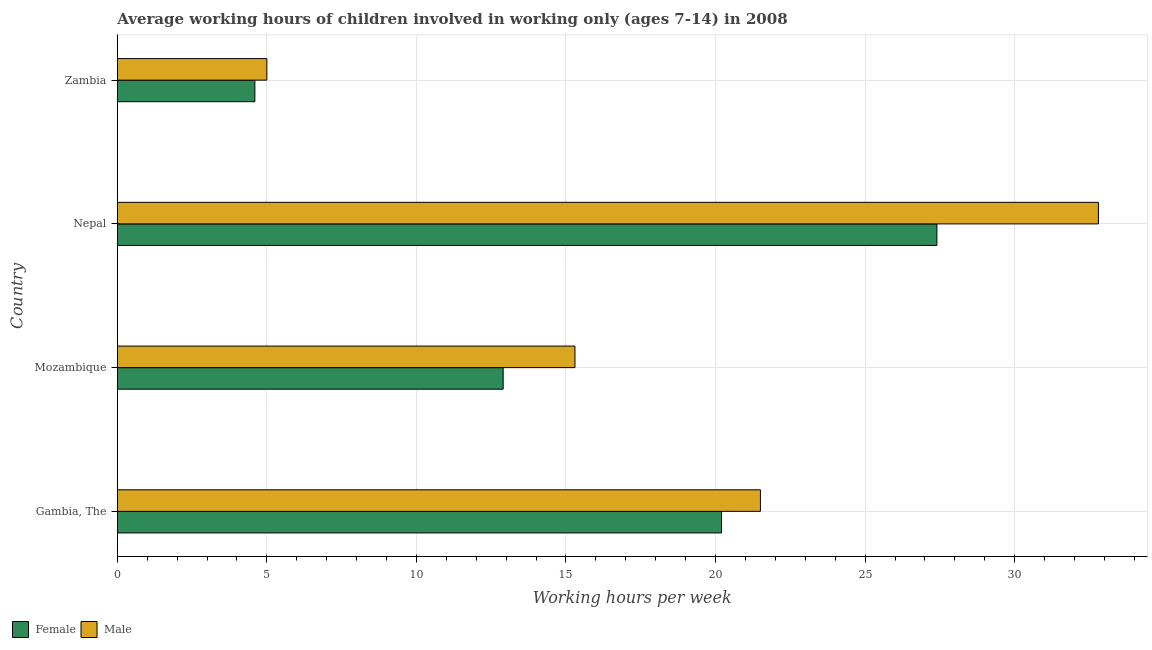How many different coloured bars are there?
Make the answer very short. 2. Are the number of bars on each tick of the Y-axis equal?
Give a very brief answer. Yes. How many bars are there on the 1st tick from the top?
Keep it short and to the point. 2. How many bars are there on the 1st tick from the bottom?
Your answer should be very brief. 2. What is the label of the 2nd group of bars from the top?
Ensure brevity in your answer.  Nepal. Across all countries, what is the maximum average working hour of female children?
Offer a very short reply. 27.4. Across all countries, what is the minimum average working hour of male children?
Offer a very short reply. 5. In which country was the average working hour of male children maximum?
Give a very brief answer. Nepal. In which country was the average working hour of female children minimum?
Your response must be concise. Zambia. What is the total average working hour of female children in the graph?
Ensure brevity in your answer.  65.1. What is the difference between the average working hour of female children in Zambia and the average working hour of male children in Gambia, The?
Ensure brevity in your answer.  -16.9. What is the average average working hour of female children per country?
Your answer should be compact. 16.27. What is the difference between the average working hour of female children and average working hour of male children in Gambia, The?
Offer a very short reply. -1.3. What is the ratio of the average working hour of female children in Gambia, The to that in Mozambique?
Make the answer very short. 1.57. Is the average working hour of female children in Gambia, The less than that in Zambia?
Keep it short and to the point. No. Is the difference between the average working hour of female children in Gambia, The and Mozambique greater than the difference between the average working hour of male children in Gambia, The and Mozambique?
Provide a short and direct response. Yes. What is the difference between the highest and the second highest average working hour of female children?
Provide a short and direct response. 7.2. What is the difference between the highest and the lowest average working hour of male children?
Make the answer very short. 27.8. In how many countries, is the average working hour of female children greater than the average average working hour of female children taken over all countries?
Your response must be concise. 2. Is the sum of the average working hour of female children in Gambia, The and Mozambique greater than the maximum average working hour of male children across all countries?
Your response must be concise. Yes. What does the 2nd bar from the bottom in Nepal represents?
Provide a short and direct response. Male. How many countries are there in the graph?
Provide a succinct answer. 4. What is the difference between two consecutive major ticks on the X-axis?
Ensure brevity in your answer.  5. Are the values on the major ticks of X-axis written in scientific E-notation?
Ensure brevity in your answer.  No. Does the graph contain any zero values?
Provide a short and direct response. No. Does the graph contain grids?
Offer a very short reply. Yes. How many legend labels are there?
Your answer should be compact. 2. What is the title of the graph?
Offer a very short reply. Average working hours of children involved in working only (ages 7-14) in 2008. Does "RDB concessional" appear as one of the legend labels in the graph?
Offer a terse response. No. What is the label or title of the X-axis?
Provide a short and direct response. Working hours per week. What is the Working hours per week of Female in Gambia, The?
Ensure brevity in your answer.  20.2. What is the Working hours per week in Male in Gambia, The?
Keep it short and to the point. 21.5. What is the Working hours per week of Female in Mozambique?
Offer a very short reply. 12.9. What is the Working hours per week in Female in Nepal?
Provide a succinct answer. 27.4. What is the Working hours per week in Male in Nepal?
Provide a succinct answer. 32.8. What is the Working hours per week of Male in Zambia?
Ensure brevity in your answer.  5. Across all countries, what is the maximum Working hours per week of Female?
Provide a succinct answer. 27.4. Across all countries, what is the maximum Working hours per week of Male?
Offer a terse response. 32.8. What is the total Working hours per week in Female in the graph?
Your answer should be compact. 65.1. What is the total Working hours per week of Male in the graph?
Provide a short and direct response. 74.6. What is the difference between the Working hours per week in Male in Gambia, The and that in Nepal?
Provide a succinct answer. -11.3. What is the difference between the Working hours per week in Female in Gambia, The and that in Zambia?
Your response must be concise. 15.6. What is the difference between the Working hours per week in Male in Gambia, The and that in Zambia?
Your answer should be compact. 16.5. What is the difference between the Working hours per week of Female in Mozambique and that in Nepal?
Make the answer very short. -14.5. What is the difference between the Working hours per week in Male in Mozambique and that in Nepal?
Ensure brevity in your answer.  -17.5. What is the difference between the Working hours per week in Male in Mozambique and that in Zambia?
Offer a very short reply. 10.3. What is the difference between the Working hours per week in Female in Nepal and that in Zambia?
Your answer should be compact. 22.8. What is the difference between the Working hours per week in Male in Nepal and that in Zambia?
Provide a succinct answer. 27.8. What is the difference between the Working hours per week of Female in Gambia, The and the Working hours per week of Male in Mozambique?
Keep it short and to the point. 4.9. What is the difference between the Working hours per week in Female in Gambia, The and the Working hours per week in Male in Nepal?
Provide a succinct answer. -12.6. What is the difference between the Working hours per week in Female in Mozambique and the Working hours per week in Male in Nepal?
Ensure brevity in your answer.  -19.9. What is the difference between the Working hours per week of Female in Mozambique and the Working hours per week of Male in Zambia?
Provide a short and direct response. 7.9. What is the difference between the Working hours per week of Female in Nepal and the Working hours per week of Male in Zambia?
Provide a short and direct response. 22.4. What is the average Working hours per week in Female per country?
Give a very brief answer. 16.27. What is the average Working hours per week in Male per country?
Make the answer very short. 18.65. What is the difference between the Working hours per week in Female and Working hours per week in Male in Gambia, The?
Keep it short and to the point. -1.3. What is the difference between the Working hours per week in Female and Working hours per week in Male in Nepal?
Keep it short and to the point. -5.4. What is the ratio of the Working hours per week in Female in Gambia, The to that in Mozambique?
Your answer should be compact. 1.57. What is the ratio of the Working hours per week in Male in Gambia, The to that in Mozambique?
Your answer should be very brief. 1.41. What is the ratio of the Working hours per week of Female in Gambia, The to that in Nepal?
Give a very brief answer. 0.74. What is the ratio of the Working hours per week in Male in Gambia, The to that in Nepal?
Your answer should be compact. 0.66. What is the ratio of the Working hours per week in Female in Gambia, The to that in Zambia?
Your answer should be very brief. 4.39. What is the ratio of the Working hours per week in Female in Mozambique to that in Nepal?
Provide a succinct answer. 0.47. What is the ratio of the Working hours per week of Male in Mozambique to that in Nepal?
Ensure brevity in your answer.  0.47. What is the ratio of the Working hours per week in Female in Mozambique to that in Zambia?
Offer a very short reply. 2.8. What is the ratio of the Working hours per week of Male in Mozambique to that in Zambia?
Provide a short and direct response. 3.06. What is the ratio of the Working hours per week in Female in Nepal to that in Zambia?
Offer a terse response. 5.96. What is the ratio of the Working hours per week in Male in Nepal to that in Zambia?
Ensure brevity in your answer.  6.56. What is the difference between the highest and the second highest Working hours per week in Male?
Your answer should be compact. 11.3. What is the difference between the highest and the lowest Working hours per week of Female?
Keep it short and to the point. 22.8. What is the difference between the highest and the lowest Working hours per week of Male?
Make the answer very short. 27.8. 